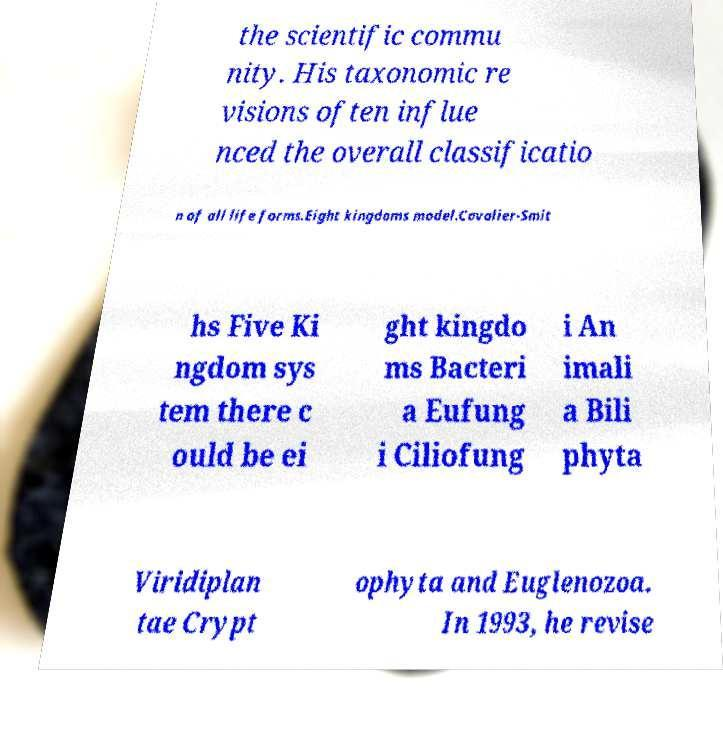Could you assist in decoding the text presented in this image and type it out clearly? the scientific commu nity. His taxonomic re visions often influe nced the overall classificatio n of all life forms.Eight kingdoms model.Cavalier-Smit hs Five Ki ngdom sys tem there c ould be ei ght kingdo ms Bacteri a Eufung i Ciliofung i An imali a Bili phyta Viridiplan tae Crypt ophyta and Euglenozoa. In 1993, he revise 